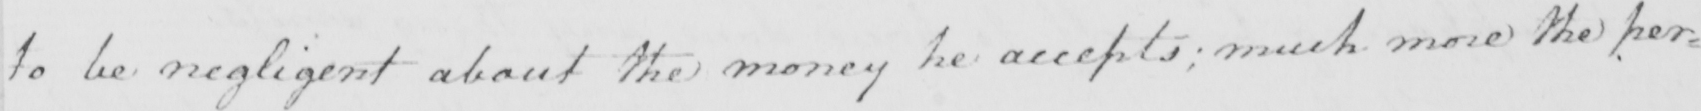Transcribe the text shown in this historical manuscript line. to be negligent about the money he accepts ; much more the per= 